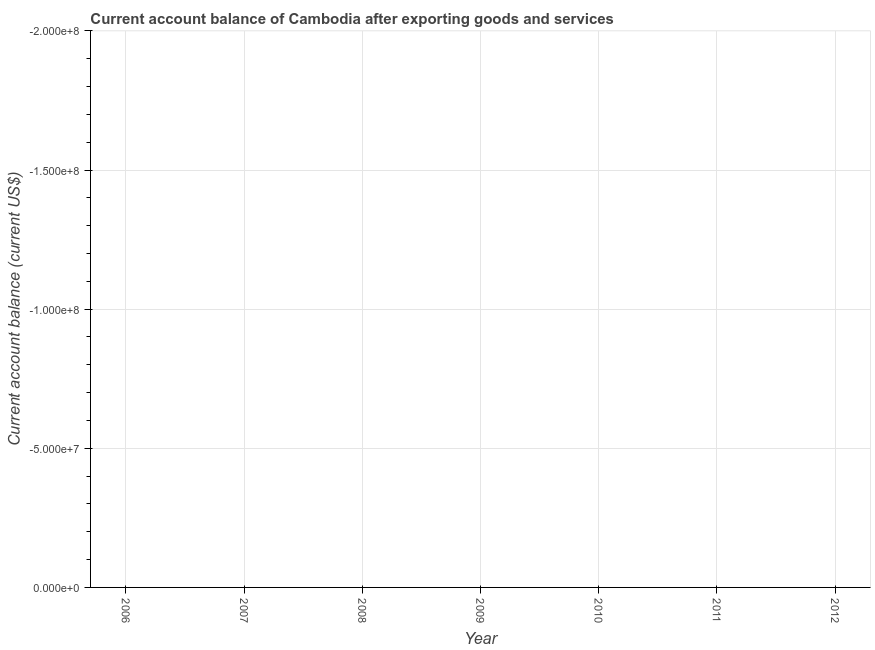What is the average current account balance per year?
Offer a terse response. 0. What is the median current account balance?
Your response must be concise. 0. How many dotlines are there?
Keep it short and to the point. 0. Are the values on the major ticks of Y-axis written in scientific E-notation?
Provide a succinct answer. Yes. Does the graph contain grids?
Your answer should be very brief. Yes. What is the title of the graph?
Keep it short and to the point. Current account balance of Cambodia after exporting goods and services. What is the label or title of the X-axis?
Your response must be concise. Year. What is the label or title of the Y-axis?
Give a very brief answer. Current account balance (current US$). What is the Current account balance (current US$) in 2006?
Provide a short and direct response. 0. What is the Current account balance (current US$) in 2009?
Your response must be concise. 0. What is the Current account balance (current US$) in 2011?
Offer a terse response. 0. What is the Current account balance (current US$) in 2012?
Offer a terse response. 0. 